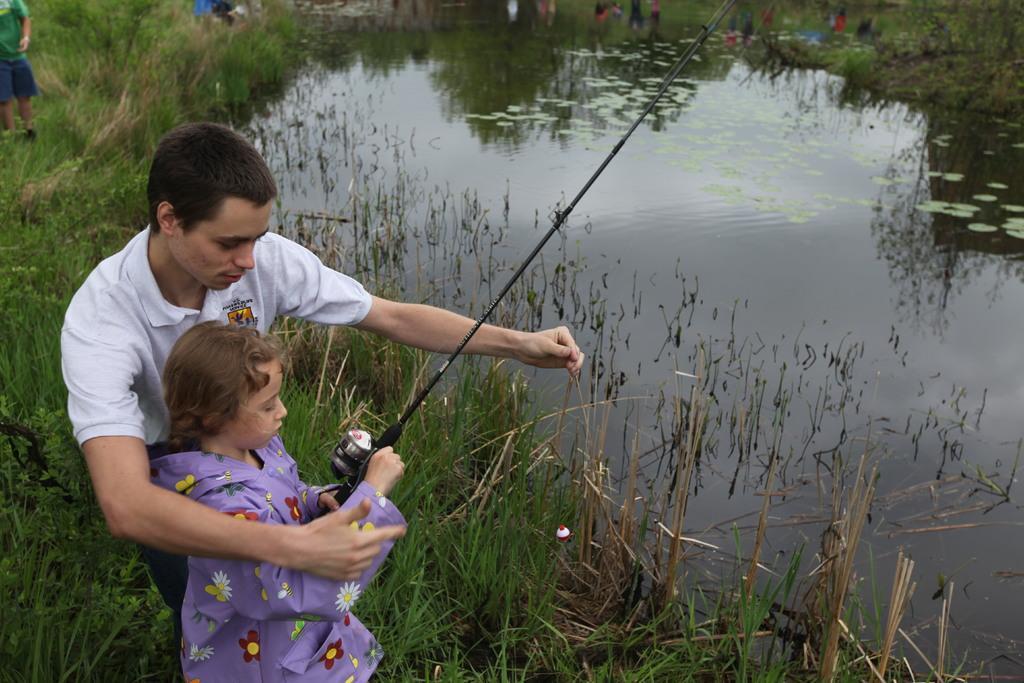Could you give a brief overview of what you see in this image? The girl in violet jacket is casting a fishing line. Beside her, the man in white T-shirt is teaching her. Beside them, we see grass. In front of them, we see water and this water might be in the pond. In the background, we see people standing. In the left top of the picture, the man in green T-shirt is standing. 